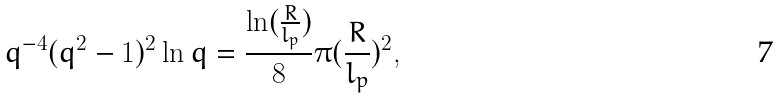<formula> <loc_0><loc_0><loc_500><loc_500>q ^ { - 4 } ( q ^ { 2 } - 1 ) ^ { 2 } \ln q = \frac { \ln ( \frac { R } { l _ { p } } ) } 8 \pi ( \frac { R } { l _ { p } } ) ^ { 2 } ,</formula> 